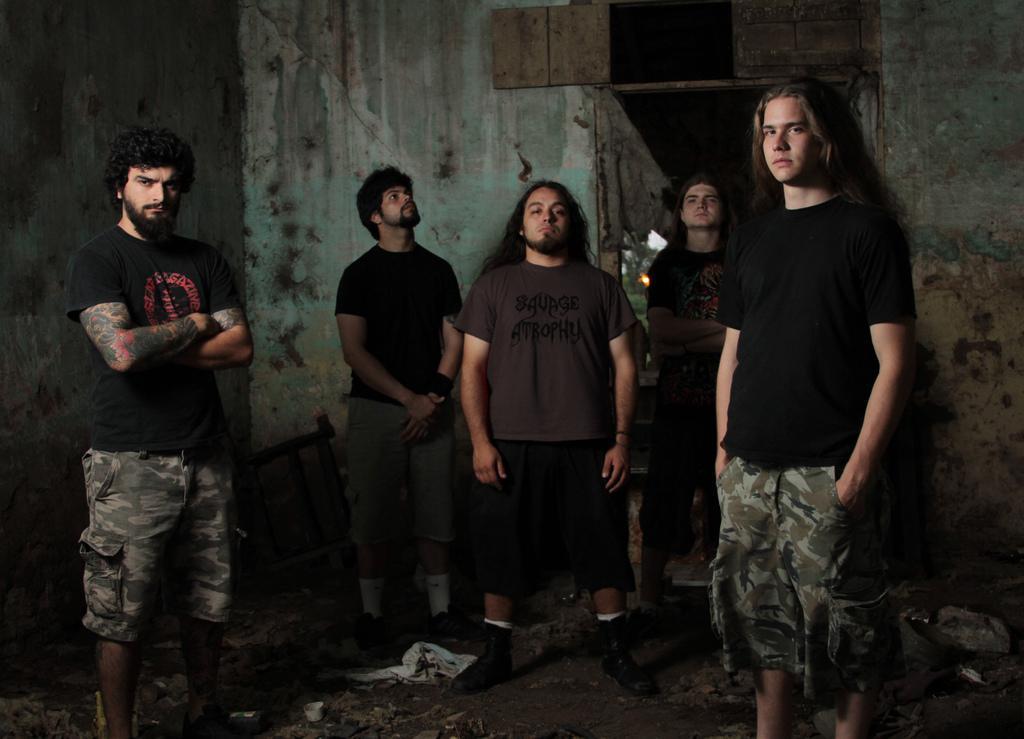Please provide a concise description of this image. This picture is clicked inside the room. In the center we can see the group of persons wearing t-shirt, shorts and standing on the ground and we can see there are some objects lying on the ground. In the background we can see the wall a wooden object and some other objects. 